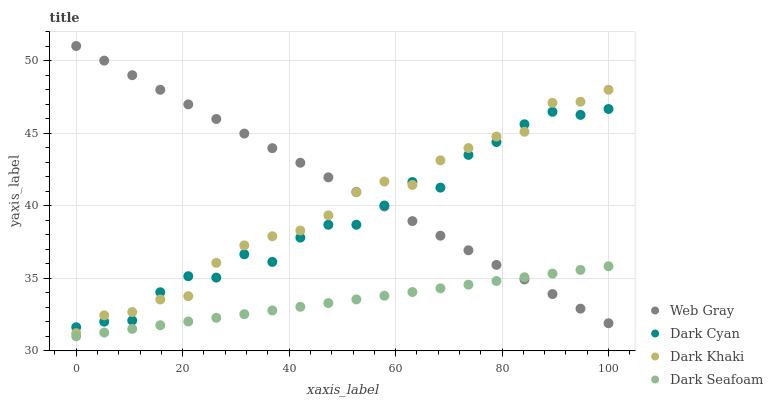Does Dark Seafoam have the minimum area under the curve?
Answer yes or no. Yes. Does Web Gray have the maximum area under the curve?
Answer yes or no. Yes. Does Dark Khaki have the minimum area under the curve?
Answer yes or no. No. Does Dark Khaki have the maximum area under the curve?
Answer yes or no. No. Is Web Gray the smoothest?
Answer yes or no. Yes. Is Dark Cyan the roughest?
Answer yes or no. Yes. Is Dark Khaki the smoothest?
Answer yes or no. No. Is Dark Khaki the roughest?
Answer yes or no. No. Does Dark Seafoam have the lowest value?
Answer yes or no. Yes. Does Dark Khaki have the lowest value?
Answer yes or no. No. Does Web Gray have the highest value?
Answer yes or no. Yes. Does Dark Khaki have the highest value?
Answer yes or no. No. Is Dark Seafoam less than Dark Khaki?
Answer yes or no. Yes. Is Dark Cyan greater than Dark Seafoam?
Answer yes or no. Yes. Does Dark Khaki intersect Web Gray?
Answer yes or no. Yes. Is Dark Khaki less than Web Gray?
Answer yes or no. No. Is Dark Khaki greater than Web Gray?
Answer yes or no. No. Does Dark Seafoam intersect Dark Khaki?
Answer yes or no. No. 